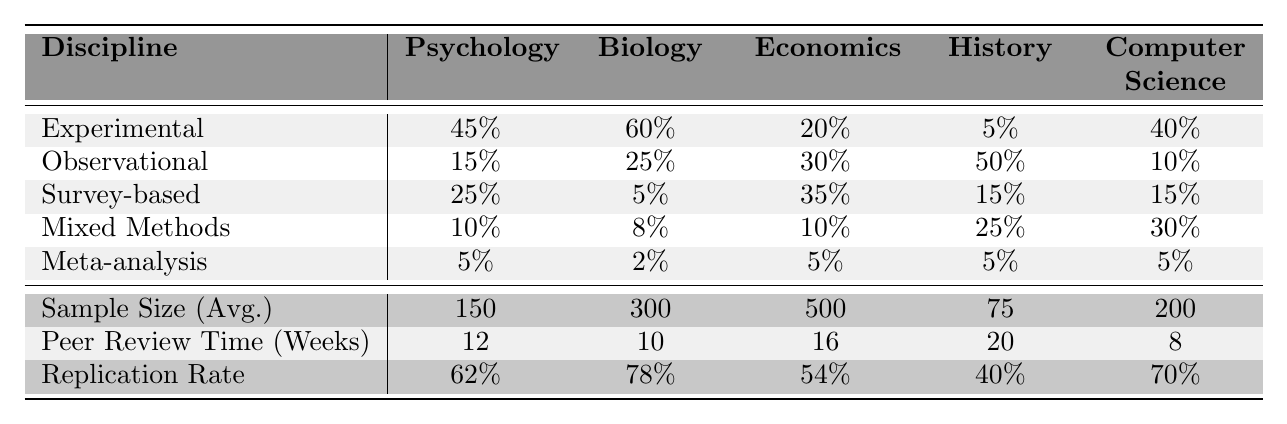What percentage of Psychology research uses observational methodology? The table shows that the percentage for Psychology under observational methodology is 15%.
Answer: 15% What is the average sample size for Economics research? The table indicates that the average sample size for Economics is 500.
Answer: 500 Which discipline has the highest replication rate, and what is that rate? The highest replication rate is found in Biology at a rate of 78%.
Answer: 78% What is the difference in average sample size between History and Biology? The average sample size for Biology is 300, while History's is 75. Thus, the difference is 300 - 75 = 225.
Answer: 225 Which methodologies are used in History research, and what percentage do they represent? The methodologies used in History are experimental (5%), observational (50%), survey-based (15%), mixed methods (25%), and meta-analysis (5%).
Answer: 5%, 50%, 15%, 25%, 5% Is the peer review time for Computer Science research shorter than for Psychology research? The peer review time for Computer Science is 8 weeks, while for Psychology it is 12 weeks. Since 8 is less than 12, the answer is yes.
Answer: Yes What is the total percentage of methodologies categorized as experimental in all disciplines combined? Adding the experimental percentages of all disciplines: 45% + 60% + 20% + 5% + 40% = 170%.
Answer: 170% Which discipline uses the fewest experimental methods? Looking at the experimental percentages, History has the lowest percentage at 5%.
Answer: History If we average the replication rate across all disciplines, what is the result? The replication rates are 62%, 78%, 54%, 40%, and 70%. Summing these gives 62 + 78 + 54 + 40 + 70 = 304, and dividing by 5 gives 304 / 5 = 60.8%.
Answer: 60.8% Which discipline has the highest percentage of survey-based methodologies? The survey-based percentage is highest in Economics at 35%.
Answer: Economics What is the total peer review time (in weeks) for Psychology and Economics combined? The peer review time for Psychology is 12 weeks and for Economics is 16 weeks. Thus, the total is 12 + 16 = 28 weeks.
Answer: 28 weeks How does the observational methodology percentage in Biology compare with that in Computer Science? The percentage for Biology is 25%, while for Computer Science it is 10%. 25% is greater than 10%.
Answer: 25% is greater than 10% What percentage of Computer Science research employs mixed methods? The mixed methods percentage for Computer Science is 30%.
Answer: 30% 